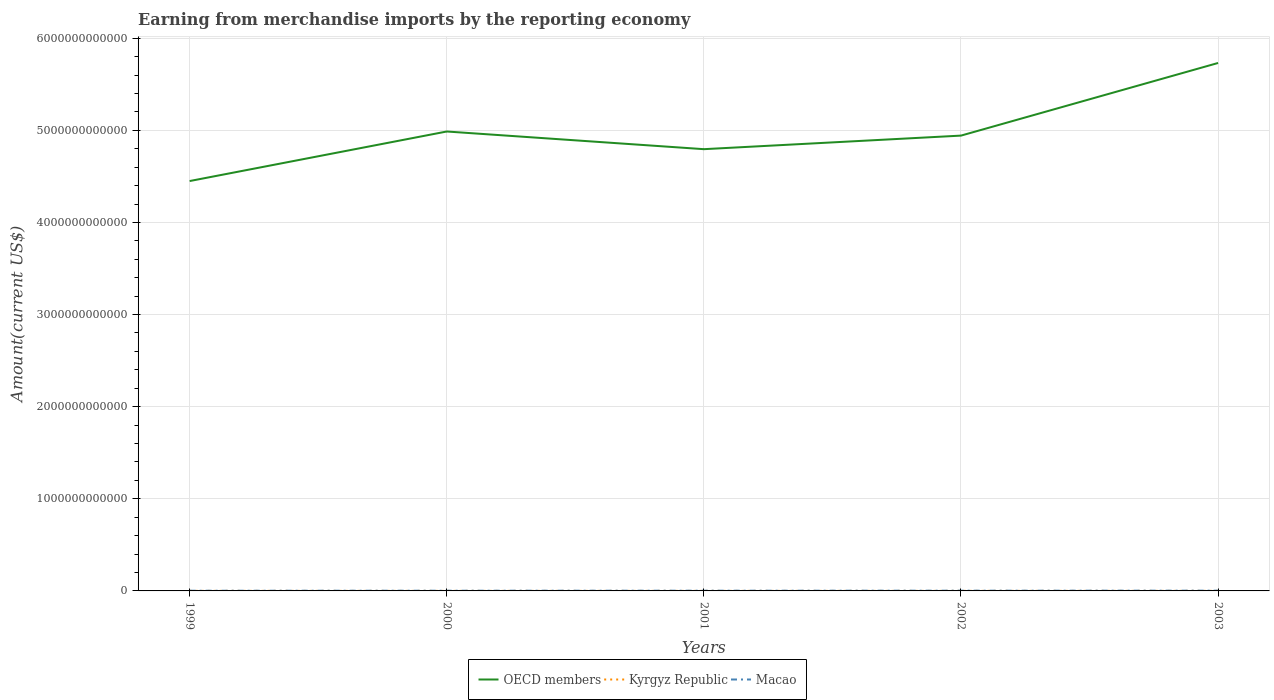Does the line corresponding to Kyrgyz Republic intersect with the line corresponding to OECD members?
Make the answer very short. No. Across all years, what is the maximum amount earned from merchandise imports in Macao?
Your answer should be compact. 2.02e+09. In which year was the amount earned from merchandise imports in OECD members maximum?
Your answer should be compact. 1999. What is the total amount earned from merchandise imports in OECD members in the graph?
Your answer should be compact. 4.47e+1. What is the difference between the highest and the second highest amount earned from merchandise imports in Macao?
Your response must be concise. 7.22e+08. What is the difference between the highest and the lowest amount earned from merchandise imports in OECD members?
Offer a terse response. 2. Is the amount earned from merchandise imports in OECD members strictly greater than the amount earned from merchandise imports in Macao over the years?
Offer a very short reply. No. What is the difference between two consecutive major ticks on the Y-axis?
Provide a short and direct response. 1.00e+12. Does the graph contain any zero values?
Offer a terse response. No. Does the graph contain grids?
Your answer should be very brief. Yes. How many legend labels are there?
Offer a very short reply. 3. What is the title of the graph?
Offer a very short reply. Earning from merchandise imports by the reporting economy. Does "Isle of Man" appear as one of the legend labels in the graph?
Provide a succinct answer. No. What is the label or title of the X-axis?
Offer a very short reply. Years. What is the label or title of the Y-axis?
Give a very brief answer. Amount(current US$). What is the Amount(current US$) of OECD members in 1999?
Your response must be concise. 4.45e+12. What is the Amount(current US$) of Kyrgyz Republic in 1999?
Make the answer very short. 6.10e+08. What is the Amount(current US$) in Macao in 1999?
Make the answer very short. 2.02e+09. What is the Amount(current US$) in OECD members in 2000?
Make the answer very short. 4.99e+12. What is the Amount(current US$) of Kyrgyz Republic in 2000?
Offer a very short reply. 5.53e+08. What is the Amount(current US$) in Macao in 2000?
Your answer should be very brief. 2.26e+09. What is the Amount(current US$) in OECD members in 2001?
Provide a short and direct response. 4.80e+12. What is the Amount(current US$) in Kyrgyz Republic in 2001?
Make the answer very short. 4.72e+08. What is the Amount(current US$) in Macao in 2001?
Offer a very short reply. 2.39e+09. What is the Amount(current US$) in OECD members in 2002?
Your answer should be compact. 4.94e+12. What is the Amount(current US$) in Kyrgyz Republic in 2002?
Provide a short and direct response. 5.87e+08. What is the Amount(current US$) of Macao in 2002?
Make the answer very short. 2.53e+09. What is the Amount(current US$) of OECD members in 2003?
Give a very brief answer. 5.73e+12. What is the Amount(current US$) of Kyrgyz Republic in 2003?
Your answer should be very brief. 7.17e+08. What is the Amount(current US$) in Macao in 2003?
Make the answer very short. 2.75e+09. Across all years, what is the maximum Amount(current US$) in OECD members?
Offer a terse response. 5.73e+12. Across all years, what is the maximum Amount(current US$) in Kyrgyz Republic?
Offer a terse response. 7.17e+08. Across all years, what is the maximum Amount(current US$) in Macao?
Ensure brevity in your answer.  2.75e+09. Across all years, what is the minimum Amount(current US$) of OECD members?
Provide a succinct answer. 4.45e+12. Across all years, what is the minimum Amount(current US$) in Kyrgyz Republic?
Provide a short and direct response. 4.72e+08. Across all years, what is the minimum Amount(current US$) of Macao?
Give a very brief answer. 2.02e+09. What is the total Amount(current US$) of OECD members in the graph?
Your answer should be very brief. 2.49e+13. What is the total Amount(current US$) of Kyrgyz Republic in the graph?
Make the answer very short. 2.94e+09. What is the total Amount(current US$) in Macao in the graph?
Provide a short and direct response. 1.19e+1. What is the difference between the Amount(current US$) of OECD members in 1999 and that in 2000?
Offer a terse response. -5.38e+11. What is the difference between the Amount(current US$) in Kyrgyz Republic in 1999 and that in 2000?
Ensure brevity in your answer.  5.75e+07. What is the difference between the Amount(current US$) of Macao in 1999 and that in 2000?
Offer a very short reply. -2.31e+08. What is the difference between the Amount(current US$) of OECD members in 1999 and that in 2001?
Your answer should be very brief. -3.46e+11. What is the difference between the Amount(current US$) of Kyrgyz Republic in 1999 and that in 2001?
Your answer should be very brief. 1.39e+08. What is the difference between the Amount(current US$) of Macao in 1999 and that in 2001?
Your answer should be very brief. -3.62e+08. What is the difference between the Amount(current US$) of OECD members in 1999 and that in 2002?
Your answer should be compact. -4.93e+11. What is the difference between the Amount(current US$) in Kyrgyz Republic in 1999 and that in 2002?
Give a very brief answer. 2.33e+07. What is the difference between the Amount(current US$) of Macao in 1999 and that in 2002?
Give a very brief answer. -5.05e+08. What is the difference between the Amount(current US$) of OECD members in 1999 and that in 2003?
Give a very brief answer. -1.28e+12. What is the difference between the Amount(current US$) in Kyrgyz Republic in 1999 and that in 2003?
Offer a terse response. -1.06e+08. What is the difference between the Amount(current US$) of Macao in 1999 and that in 2003?
Ensure brevity in your answer.  -7.22e+08. What is the difference between the Amount(current US$) in OECD members in 2000 and that in 2001?
Offer a very short reply. 1.92e+11. What is the difference between the Amount(current US$) in Kyrgyz Republic in 2000 and that in 2001?
Your response must be concise. 8.14e+07. What is the difference between the Amount(current US$) in Macao in 2000 and that in 2001?
Provide a succinct answer. -1.32e+08. What is the difference between the Amount(current US$) of OECD members in 2000 and that in 2002?
Provide a succinct answer. 4.47e+1. What is the difference between the Amount(current US$) in Kyrgyz Republic in 2000 and that in 2002?
Ensure brevity in your answer.  -3.42e+07. What is the difference between the Amount(current US$) of Macao in 2000 and that in 2002?
Offer a terse response. -2.75e+08. What is the difference between the Amount(current US$) of OECD members in 2000 and that in 2003?
Provide a short and direct response. -7.44e+11. What is the difference between the Amount(current US$) in Kyrgyz Republic in 2000 and that in 2003?
Ensure brevity in your answer.  -1.64e+08. What is the difference between the Amount(current US$) of Macao in 2000 and that in 2003?
Make the answer very short. -4.92e+08. What is the difference between the Amount(current US$) of OECD members in 2001 and that in 2002?
Your response must be concise. -1.47e+11. What is the difference between the Amount(current US$) of Kyrgyz Republic in 2001 and that in 2002?
Your answer should be compact. -1.16e+08. What is the difference between the Amount(current US$) in Macao in 2001 and that in 2002?
Offer a very short reply. -1.43e+08. What is the difference between the Amount(current US$) in OECD members in 2001 and that in 2003?
Offer a terse response. -9.36e+11. What is the difference between the Amount(current US$) in Kyrgyz Republic in 2001 and that in 2003?
Your response must be concise. -2.45e+08. What is the difference between the Amount(current US$) of Macao in 2001 and that in 2003?
Your answer should be compact. -3.60e+08. What is the difference between the Amount(current US$) of OECD members in 2002 and that in 2003?
Your answer should be compact. -7.89e+11. What is the difference between the Amount(current US$) in Kyrgyz Republic in 2002 and that in 2003?
Provide a succinct answer. -1.30e+08. What is the difference between the Amount(current US$) in Macao in 2002 and that in 2003?
Offer a very short reply. -2.17e+08. What is the difference between the Amount(current US$) in OECD members in 1999 and the Amount(current US$) in Kyrgyz Republic in 2000?
Give a very brief answer. 4.45e+12. What is the difference between the Amount(current US$) of OECD members in 1999 and the Amount(current US$) of Macao in 2000?
Keep it short and to the point. 4.45e+12. What is the difference between the Amount(current US$) in Kyrgyz Republic in 1999 and the Amount(current US$) in Macao in 2000?
Offer a terse response. -1.64e+09. What is the difference between the Amount(current US$) of OECD members in 1999 and the Amount(current US$) of Kyrgyz Republic in 2001?
Offer a very short reply. 4.45e+12. What is the difference between the Amount(current US$) of OECD members in 1999 and the Amount(current US$) of Macao in 2001?
Offer a terse response. 4.45e+12. What is the difference between the Amount(current US$) of Kyrgyz Republic in 1999 and the Amount(current US$) of Macao in 2001?
Make the answer very short. -1.78e+09. What is the difference between the Amount(current US$) of OECD members in 1999 and the Amount(current US$) of Kyrgyz Republic in 2002?
Offer a terse response. 4.45e+12. What is the difference between the Amount(current US$) in OECD members in 1999 and the Amount(current US$) in Macao in 2002?
Keep it short and to the point. 4.45e+12. What is the difference between the Amount(current US$) of Kyrgyz Republic in 1999 and the Amount(current US$) of Macao in 2002?
Offer a terse response. -1.92e+09. What is the difference between the Amount(current US$) of OECD members in 1999 and the Amount(current US$) of Kyrgyz Republic in 2003?
Your response must be concise. 4.45e+12. What is the difference between the Amount(current US$) of OECD members in 1999 and the Amount(current US$) of Macao in 2003?
Provide a short and direct response. 4.45e+12. What is the difference between the Amount(current US$) of Kyrgyz Republic in 1999 and the Amount(current US$) of Macao in 2003?
Provide a short and direct response. -2.14e+09. What is the difference between the Amount(current US$) of OECD members in 2000 and the Amount(current US$) of Kyrgyz Republic in 2001?
Provide a succinct answer. 4.99e+12. What is the difference between the Amount(current US$) in OECD members in 2000 and the Amount(current US$) in Macao in 2001?
Provide a short and direct response. 4.99e+12. What is the difference between the Amount(current US$) of Kyrgyz Republic in 2000 and the Amount(current US$) of Macao in 2001?
Your response must be concise. -1.83e+09. What is the difference between the Amount(current US$) in OECD members in 2000 and the Amount(current US$) in Kyrgyz Republic in 2002?
Provide a succinct answer. 4.99e+12. What is the difference between the Amount(current US$) in OECD members in 2000 and the Amount(current US$) in Macao in 2002?
Make the answer very short. 4.98e+12. What is the difference between the Amount(current US$) of Kyrgyz Republic in 2000 and the Amount(current US$) of Macao in 2002?
Make the answer very short. -1.98e+09. What is the difference between the Amount(current US$) of OECD members in 2000 and the Amount(current US$) of Kyrgyz Republic in 2003?
Make the answer very short. 4.99e+12. What is the difference between the Amount(current US$) in OECD members in 2000 and the Amount(current US$) in Macao in 2003?
Offer a terse response. 4.98e+12. What is the difference between the Amount(current US$) in Kyrgyz Republic in 2000 and the Amount(current US$) in Macao in 2003?
Give a very brief answer. -2.19e+09. What is the difference between the Amount(current US$) in OECD members in 2001 and the Amount(current US$) in Kyrgyz Republic in 2002?
Offer a very short reply. 4.80e+12. What is the difference between the Amount(current US$) in OECD members in 2001 and the Amount(current US$) in Macao in 2002?
Your answer should be compact. 4.79e+12. What is the difference between the Amount(current US$) of Kyrgyz Republic in 2001 and the Amount(current US$) of Macao in 2002?
Your answer should be compact. -2.06e+09. What is the difference between the Amount(current US$) in OECD members in 2001 and the Amount(current US$) in Kyrgyz Republic in 2003?
Give a very brief answer. 4.79e+12. What is the difference between the Amount(current US$) in OECD members in 2001 and the Amount(current US$) in Macao in 2003?
Provide a succinct answer. 4.79e+12. What is the difference between the Amount(current US$) of Kyrgyz Republic in 2001 and the Amount(current US$) of Macao in 2003?
Offer a very short reply. -2.28e+09. What is the difference between the Amount(current US$) in OECD members in 2002 and the Amount(current US$) in Kyrgyz Republic in 2003?
Keep it short and to the point. 4.94e+12. What is the difference between the Amount(current US$) in OECD members in 2002 and the Amount(current US$) in Macao in 2003?
Keep it short and to the point. 4.94e+12. What is the difference between the Amount(current US$) of Kyrgyz Republic in 2002 and the Amount(current US$) of Macao in 2003?
Your answer should be compact. -2.16e+09. What is the average Amount(current US$) in OECD members per year?
Offer a very short reply. 4.98e+12. What is the average Amount(current US$) of Kyrgyz Republic per year?
Offer a very short reply. 5.88e+08. What is the average Amount(current US$) in Macao per year?
Make the answer very short. 2.39e+09. In the year 1999, what is the difference between the Amount(current US$) of OECD members and Amount(current US$) of Kyrgyz Republic?
Give a very brief answer. 4.45e+12. In the year 1999, what is the difference between the Amount(current US$) in OECD members and Amount(current US$) in Macao?
Make the answer very short. 4.45e+12. In the year 1999, what is the difference between the Amount(current US$) in Kyrgyz Republic and Amount(current US$) in Macao?
Make the answer very short. -1.41e+09. In the year 2000, what is the difference between the Amount(current US$) of OECD members and Amount(current US$) of Kyrgyz Republic?
Provide a short and direct response. 4.99e+12. In the year 2000, what is the difference between the Amount(current US$) of OECD members and Amount(current US$) of Macao?
Provide a succinct answer. 4.99e+12. In the year 2000, what is the difference between the Amount(current US$) in Kyrgyz Republic and Amount(current US$) in Macao?
Provide a succinct answer. -1.70e+09. In the year 2001, what is the difference between the Amount(current US$) in OECD members and Amount(current US$) in Kyrgyz Republic?
Make the answer very short. 4.80e+12. In the year 2001, what is the difference between the Amount(current US$) in OECD members and Amount(current US$) in Macao?
Your response must be concise. 4.79e+12. In the year 2001, what is the difference between the Amount(current US$) in Kyrgyz Republic and Amount(current US$) in Macao?
Provide a short and direct response. -1.92e+09. In the year 2002, what is the difference between the Amount(current US$) in OECD members and Amount(current US$) in Kyrgyz Republic?
Offer a very short reply. 4.94e+12. In the year 2002, what is the difference between the Amount(current US$) in OECD members and Amount(current US$) in Macao?
Give a very brief answer. 4.94e+12. In the year 2002, what is the difference between the Amount(current US$) in Kyrgyz Republic and Amount(current US$) in Macao?
Keep it short and to the point. -1.94e+09. In the year 2003, what is the difference between the Amount(current US$) of OECD members and Amount(current US$) of Kyrgyz Republic?
Your answer should be compact. 5.73e+12. In the year 2003, what is the difference between the Amount(current US$) of OECD members and Amount(current US$) of Macao?
Make the answer very short. 5.73e+12. In the year 2003, what is the difference between the Amount(current US$) of Kyrgyz Republic and Amount(current US$) of Macao?
Give a very brief answer. -2.03e+09. What is the ratio of the Amount(current US$) in OECD members in 1999 to that in 2000?
Your response must be concise. 0.89. What is the ratio of the Amount(current US$) of Kyrgyz Republic in 1999 to that in 2000?
Ensure brevity in your answer.  1.1. What is the ratio of the Amount(current US$) in Macao in 1999 to that in 2000?
Your answer should be compact. 0.9. What is the ratio of the Amount(current US$) of OECD members in 1999 to that in 2001?
Provide a short and direct response. 0.93. What is the ratio of the Amount(current US$) of Kyrgyz Republic in 1999 to that in 2001?
Provide a succinct answer. 1.29. What is the ratio of the Amount(current US$) of Macao in 1999 to that in 2001?
Give a very brief answer. 0.85. What is the ratio of the Amount(current US$) in OECD members in 1999 to that in 2002?
Provide a succinct answer. 0.9. What is the ratio of the Amount(current US$) in Kyrgyz Republic in 1999 to that in 2002?
Give a very brief answer. 1.04. What is the ratio of the Amount(current US$) in Macao in 1999 to that in 2002?
Offer a very short reply. 0.8. What is the ratio of the Amount(current US$) in OECD members in 1999 to that in 2003?
Give a very brief answer. 0.78. What is the ratio of the Amount(current US$) in Kyrgyz Republic in 1999 to that in 2003?
Make the answer very short. 0.85. What is the ratio of the Amount(current US$) of Macao in 1999 to that in 2003?
Give a very brief answer. 0.74. What is the ratio of the Amount(current US$) in Kyrgyz Republic in 2000 to that in 2001?
Offer a very short reply. 1.17. What is the ratio of the Amount(current US$) of Macao in 2000 to that in 2001?
Provide a short and direct response. 0.94. What is the ratio of the Amount(current US$) in Kyrgyz Republic in 2000 to that in 2002?
Keep it short and to the point. 0.94. What is the ratio of the Amount(current US$) of Macao in 2000 to that in 2002?
Give a very brief answer. 0.89. What is the ratio of the Amount(current US$) in OECD members in 2000 to that in 2003?
Make the answer very short. 0.87. What is the ratio of the Amount(current US$) in Kyrgyz Republic in 2000 to that in 2003?
Offer a terse response. 0.77. What is the ratio of the Amount(current US$) in Macao in 2000 to that in 2003?
Offer a very short reply. 0.82. What is the ratio of the Amount(current US$) of OECD members in 2001 to that in 2002?
Provide a succinct answer. 0.97. What is the ratio of the Amount(current US$) of Kyrgyz Republic in 2001 to that in 2002?
Keep it short and to the point. 0.8. What is the ratio of the Amount(current US$) in Macao in 2001 to that in 2002?
Provide a short and direct response. 0.94. What is the ratio of the Amount(current US$) in OECD members in 2001 to that in 2003?
Keep it short and to the point. 0.84. What is the ratio of the Amount(current US$) of Kyrgyz Republic in 2001 to that in 2003?
Give a very brief answer. 0.66. What is the ratio of the Amount(current US$) in Macao in 2001 to that in 2003?
Offer a very short reply. 0.87. What is the ratio of the Amount(current US$) in OECD members in 2002 to that in 2003?
Your answer should be compact. 0.86. What is the ratio of the Amount(current US$) of Kyrgyz Republic in 2002 to that in 2003?
Provide a short and direct response. 0.82. What is the ratio of the Amount(current US$) in Macao in 2002 to that in 2003?
Your answer should be very brief. 0.92. What is the difference between the highest and the second highest Amount(current US$) of OECD members?
Give a very brief answer. 7.44e+11. What is the difference between the highest and the second highest Amount(current US$) in Kyrgyz Republic?
Offer a terse response. 1.06e+08. What is the difference between the highest and the second highest Amount(current US$) in Macao?
Your answer should be very brief. 2.17e+08. What is the difference between the highest and the lowest Amount(current US$) in OECD members?
Provide a succinct answer. 1.28e+12. What is the difference between the highest and the lowest Amount(current US$) in Kyrgyz Republic?
Ensure brevity in your answer.  2.45e+08. What is the difference between the highest and the lowest Amount(current US$) of Macao?
Your answer should be very brief. 7.22e+08. 